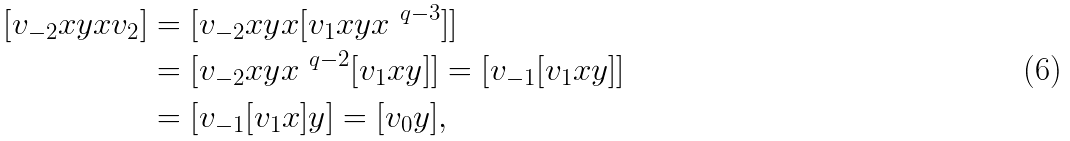Convert formula to latex. <formula><loc_0><loc_0><loc_500><loc_500>[ v _ { - 2 } x y x v _ { 2 } ] & = [ v _ { - 2 } x y x [ v _ { 1 } x y x ^ { \ q - 3 } ] ] \\ & = [ v _ { - 2 } x y x ^ { \ q - 2 } [ v _ { 1 } x y ] ] = [ v _ { - 1 } [ v _ { 1 } x y ] ] \\ & = [ v _ { - 1 } [ v _ { 1 } x ] y ] = [ v _ { 0 } y ] ,</formula> 